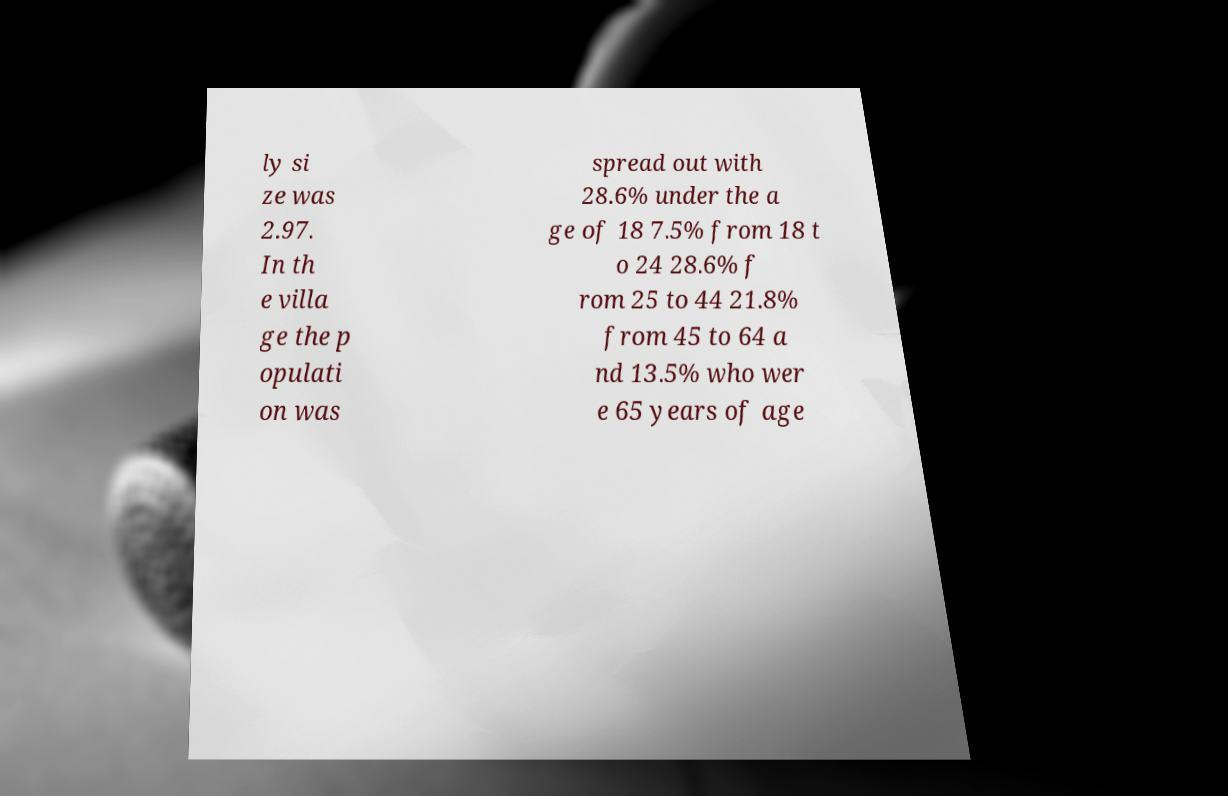For documentation purposes, I need the text within this image transcribed. Could you provide that? ly si ze was 2.97. In th e villa ge the p opulati on was spread out with 28.6% under the a ge of 18 7.5% from 18 t o 24 28.6% f rom 25 to 44 21.8% from 45 to 64 a nd 13.5% who wer e 65 years of age 